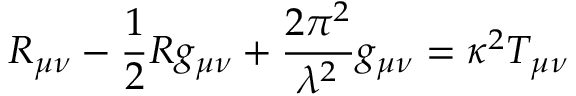Convert formula to latex. <formula><loc_0><loc_0><loc_500><loc_500>R _ { \mu \nu } - \frac { 1 } { 2 } R g _ { \mu \nu } + \frac { 2 \pi ^ { 2 } } { { \lambda } ^ { 2 } } g _ { \mu \nu } = \kappa ^ { 2 } T _ { \mu \nu }</formula> 